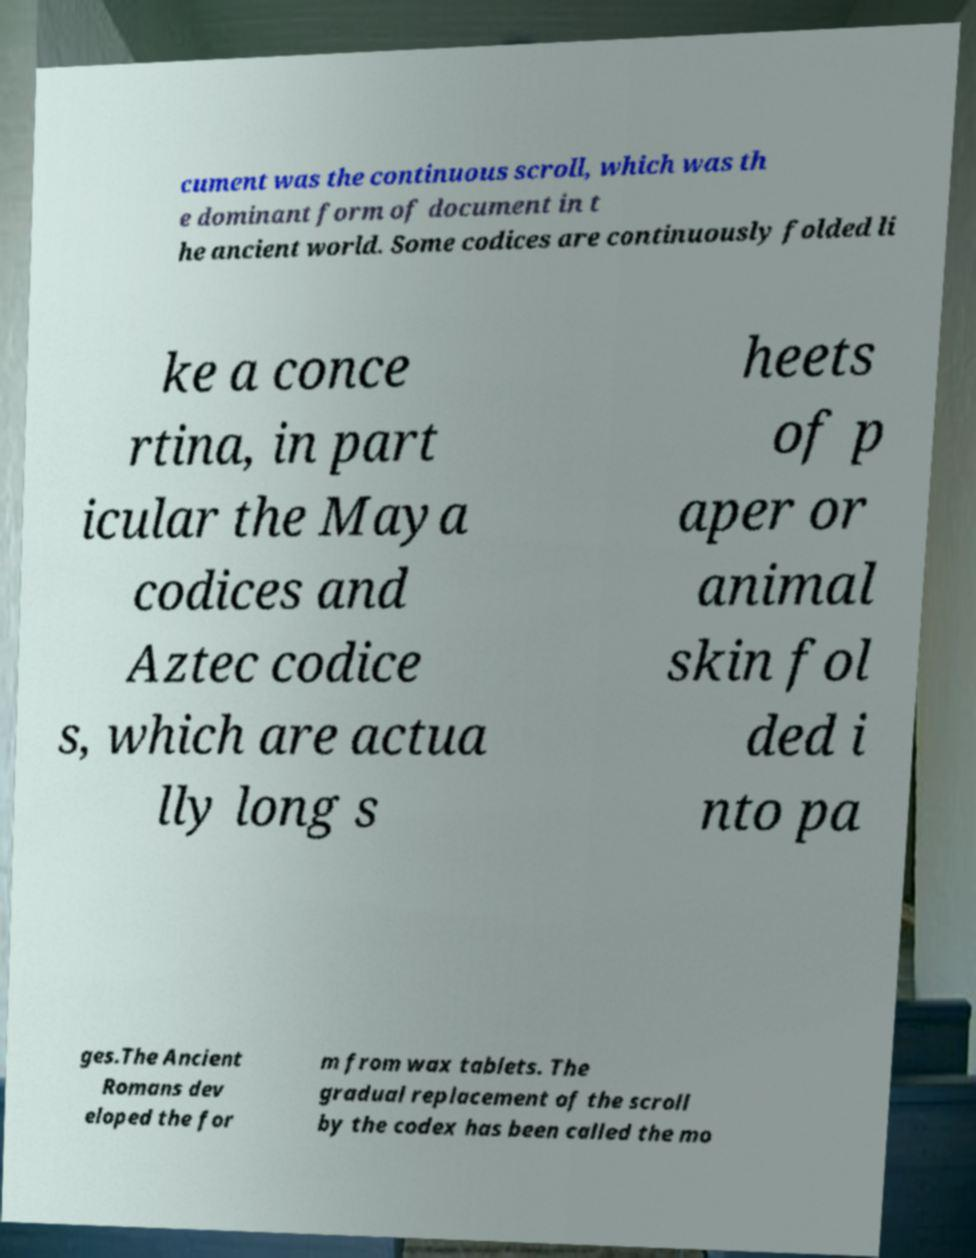Could you assist in decoding the text presented in this image and type it out clearly? cument was the continuous scroll, which was th e dominant form of document in t he ancient world. Some codices are continuously folded li ke a conce rtina, in part icular the Maya codices and Aztec codice s, which are actua lly long s heets of p aper or animal skin fol ded i nto pa ges.The Ancient Romans dev eloped the for m from wax tablets. The gradual replacement of the scroll by the codex has been called the mo 